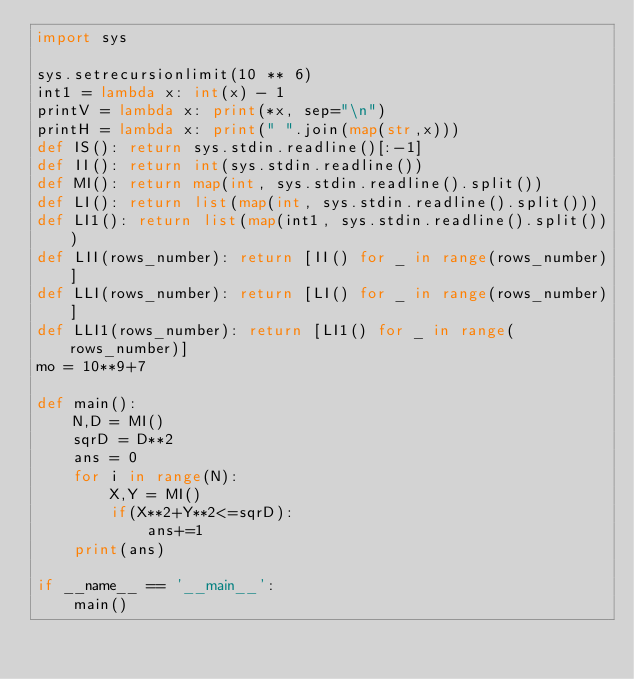Convert code to text. <code><loc_0><loc_0><loc_500><loc_500><_Python_>import sys

sys.setrecursionlimit(10 ** 6)
int1 = lambda x: int(x) - 1
printV = lambda x: print(*x, sep="\n")
printH = lambda x: print(" ".join(map(str,x)))
def IS(): return sys.stdin.readline()[:-1]
def II(): return int(sys.stdin.readline())
def MI(): return map(int, sys.stdin.readline().split())
def LI(): return list(map(int, sys.stdin.readline().split()))
def LI1(): return list(map(int1, sys.stdin.readline().split()))
def LII(rows_number): return [II() for _ in range(rows_number)]
def LLI(rows_number): return [LI() for _ in range(rows_number)]
def LLI1(rows_number): return [LI1() for _ in range(rows_number)]
mo = 10**9+7

def main():
    N,D = MI()
    sqrD = D**2
    ans = 0
    for i in range(N):
        X,Y = MI()
        if(X**2+Y**2<=sqrD):
            ans+=1
    print(ans)

if __name__ == '__main__':
    main()</code> 